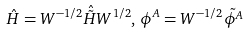Convert formula to latex. <formula><loc_0><loc_0><loc_500><loc_500>\hat { H } = W ^ { - 1 / 2 } \hat { \tilde { H } } W ^ { 1 / 2 } , \, \phi ^ { A } = W ^ { - 1 / 2 } \tilde { \phi ^ { A } }</formula> 